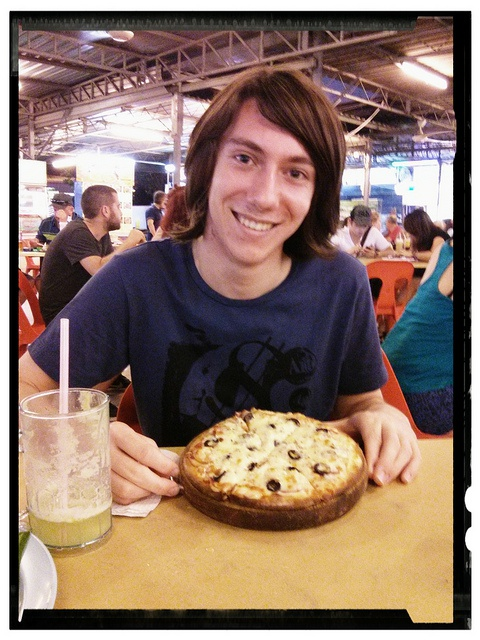Describe the objects in this image and their specific colors. I can see people in white, black, lightpink, navy, and brown tones, dining table in white and tan tones, pizza in white, khaki, tan, beige, and brown tones, cup in white, tan, and lightgray tones, and people in white, blue, darkblue, black, and teal tones in this image. 